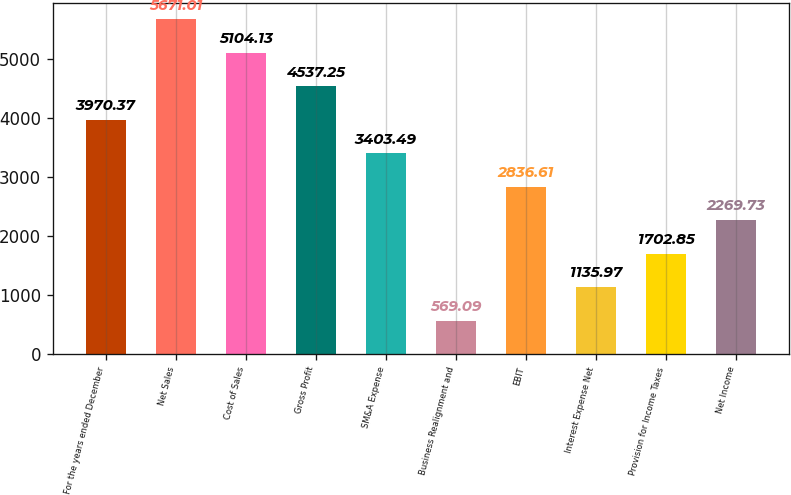Convert chart. <chart><loc_0><loc_0><loc_500><loc_500><bar_chart><fcel>For the years ended December<fcel>Net Sales<fcel>Cost of Sales<fcel>Gross Profit<fcel>SM&A Expense<fcel>Business Realignment and<fcel>EBIT<fcel>Interest Expense Net<fcel>Provision for Income Taxes<fcel>Net Income<nl><fcel>3970.37<fcel>5671.01<fcel>5104.13<fcel>4537.25<fcel>3403.49<fcel>569.09<fcel>2836.61<fcel>1135.97<fcel>1702.85<fcel>2269.73<nl></chart> 